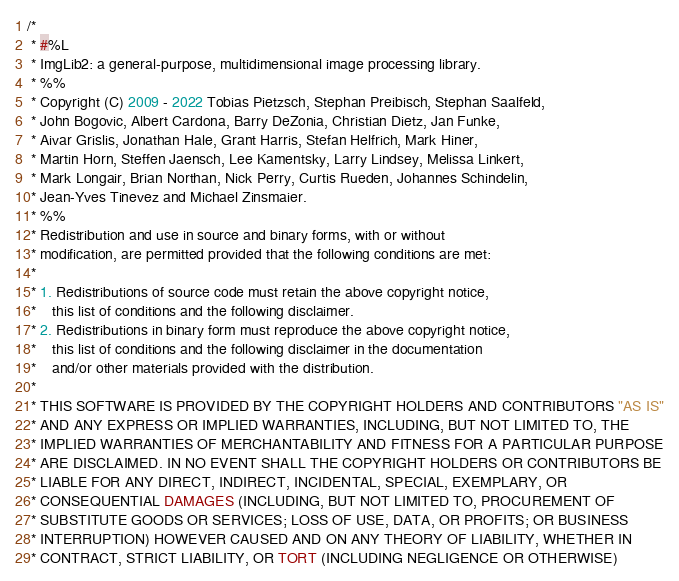Convert code to text. <code><loc_0><loc_0><loc_500><loc_500><_Java_>/*
 * #%L
 * ImgLib2: a general-purpose, multidimensional image processing library.
 * %%
 * Copyright (C) 2009 - 2022 Tobias Pietzsch, Stephan Preibisch, Stephan Saalfeld,
 * John Bogovic, Albert Cardona, Barry DeZonia, Christian Dietz, Jan Funke,
 * Aivar Grislis, Jonathan Hale, Grant Harris, Stefan Helfrich, Mark Hiner,
 * Martin Horn, Steffen Jaensch, Lee Kamentsky, Larry Lindsey, Melissa Linkert,
 * Mark Longair, Brian Northan, Nick Perry, Curtis Rueden, Johannes Schindelin,
 * Jean-Yves Tinevez and Michael Zinsmaier.
 * %%
 * Redistribution and use in source and binary forms, with or without
 * modification, are permitted provided that the following conditions are met:
 * 
 * 1. Redistributions of source code must retain the above copyright notice,
 *    this list of conditions and the following disclaimer.
 * 2. Redistributions in binary form must reproduce the above copyright notice,
 *    this list of conditions and the following disclaimer in the documentation
 *    and/or other materials provided with the distribution.
 * 
 * THIS SOFTWARE IS PROVIDED BY THE COPYRIGHT HOLDERS AND CONTRIBUTORS "AS IS"
 * AND ANY EXPRESS OR IMPLIED WARRANTIES, INCLUDING, BUT NOT LIMITED TO, THE
 * IMPLIED WARRANTIES OF MERCHANTABILITY AND FITNESS FOR A PARTICULAR PURPOSE
 * ARE DISCLAIMED. IN NO EVENT SHALL THE COPYRIGHT HOLDERS OR CONTRIBUTORS BE
 * LIABLE FOR ANY DIRECT, INDIRECT, INCIDENTAL, SPECIAL, EXEMPLARY, OR
 * CONSEQUENTIAL DAMAGES (INCLUDING, BUT NOT LIMITED TO, PROCUREMENT OF
 * SUBSTITUTE GOODS OR SERVICES; LOSS OF USE, DATA, OR PROFITS; OR BUSINESS
 * INTERRUPTION) HOWEVER CAUSED AND ON ANY THEORY OF LIABILITY, WHETHER IN
 * CONTRACT, STRICT LIABILITY, OR TORT (INCLUDING NEGLIGENCE OR OTHERWISE)</code> 